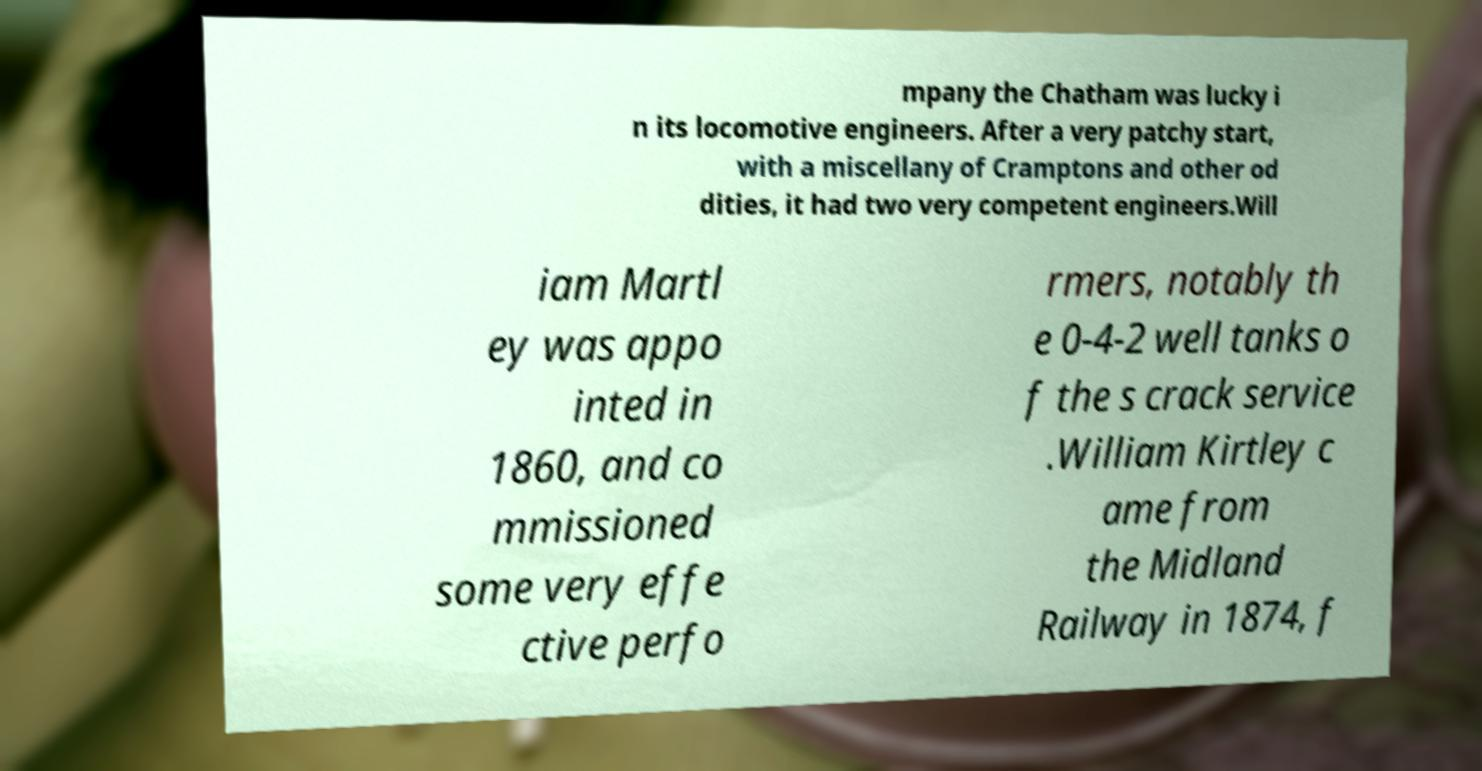Please read and relay the text visible in this image. What does it say? mpany the Chatham was lucky i n its locomotive engineers. After a very patchy start, with a miscellany of Cramptons and other od dities, it had two very competent engineers.Will iam Martl ey was appo inted in 1860, and co mmissioned some very effe ctive perfo rmers, notably th e 0-4-2 well tanks o f the s crack service .William Kirtley c ame from the Midland Railway in 1874, f 